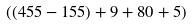<formula> <loc_0><loc_0><loc_500><loc_500>( ( 4 5 5 - 1 5 5 ) + 9 + 8 0 + 5 )</formula> 